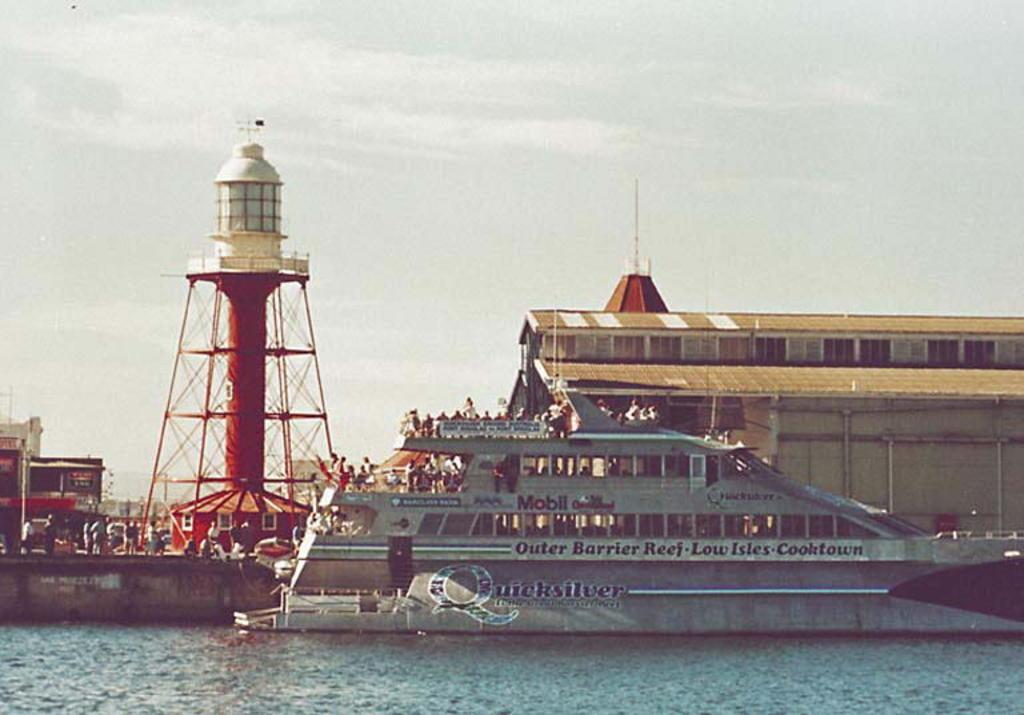<image>
Offer a succinct explanation of the picture presented. The Outer Barrier Reef - Low Isles - Cooktown ferry is at the cock. 